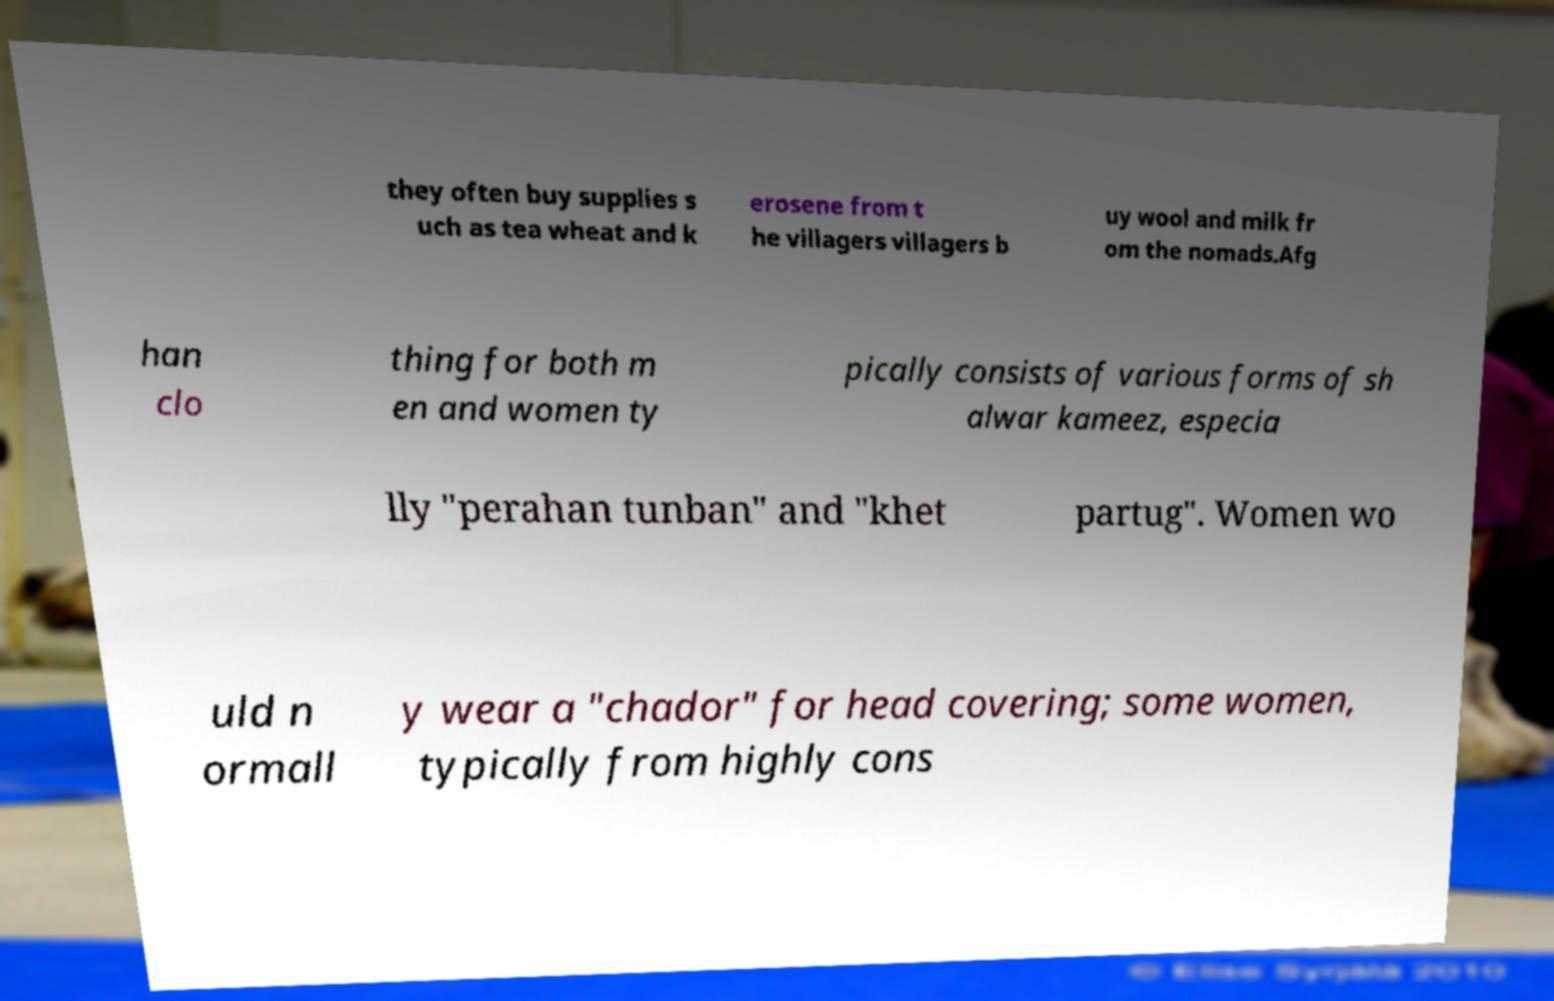Could you extract and type out the text from this image? they often buy supplies s uch as tea wheat and k erosene from t he villagers villagers b uy wool and milk fr om the nomads.Afg han clo thing for both m en and women ty pically consists of various forms of sh alwar kameez, especia lly "perahan tunban" and "khet partug". Women wo uld n ormall y wear a "chador" for head covering; some women, typically from highly cons 